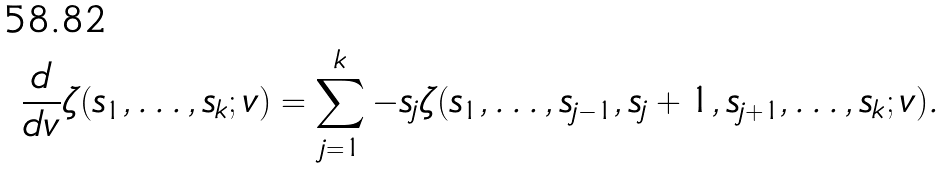Convert formula to latex. <formula><loc_0><loc_0><loc_500><loc_500>\frac { d } { d v } \zeta ( s _ { 1 } , \dots , s _ { k } ; v ) = \sum _ { j = 1 } ^ { k } - s _ { j } \zeta ( s _ { 1 } , \dots , s _ { j - 1 } , s _ { j } + 1 , s _ { j + 1 } , \dots , s _ { k } ; v ) .</formula> 